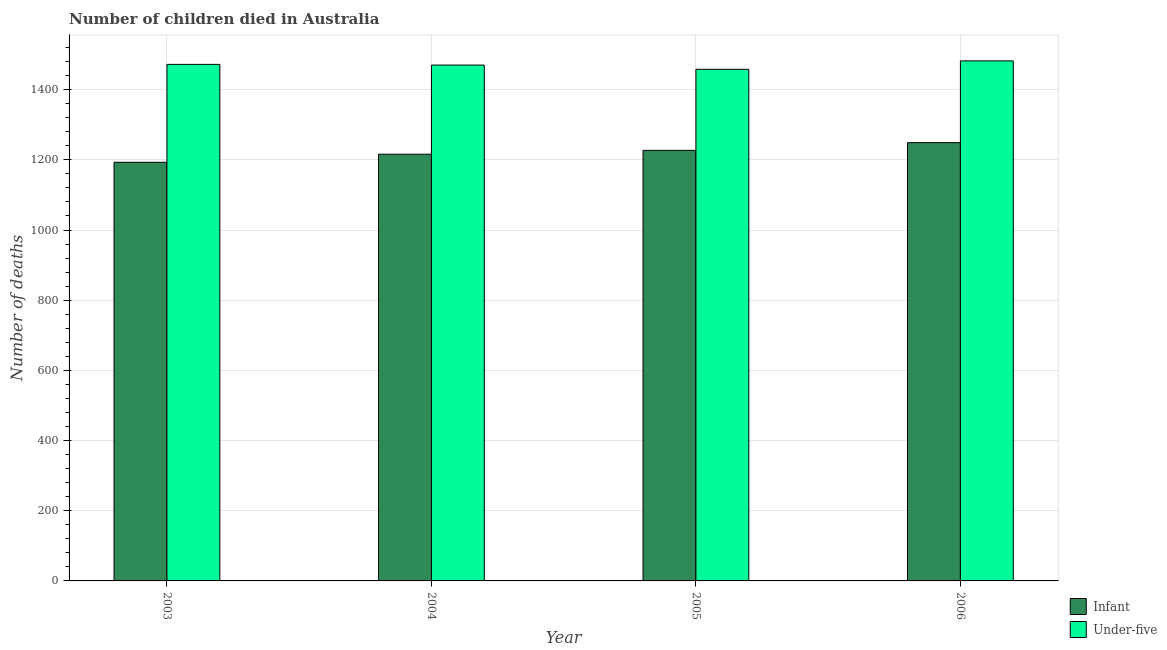How many groups of bars are there?
Your answer should be very brief. 4. Are the number of bars per tick equal to the number of legend labels?
Make the answer very short. Yes. What is the label of the 1st group of bars from the left?
Keep it short and to the point. 2003. In how many cases, is the number of bars for a given year not equal to the number of legend labels?
Give a very brief answer. 0. What is the number of under-five deaths in 2004?
Keep it short and to the point. 1470. Across all years, what is the maximum number of infant deaths?
Offer a very short reply. 1249. Across all years, what is the minimum number of infant deaths?
Provide a short and direct response. 1193. In which year was the number of infant deaths maximum?
Give a very brief answer. 2006. In which year was the number of under-five deaths minimum?
Provide a short and direct response. 2005. What is the total number of infant deaths in the graph?
Give a very brief answer. 4885. What is the difference between the number of infant deaths in 2004 and that in 2005?
Keep it short and to the point. -11. What is the difference between the number of infant deaths in 2003 and the number of under-five deaths in 2005?
Give a very brief answer. -34. What is the average number of under-five deaths per year?
Offer a very short reply. 1470.5. In how many years, is the number of under-five deaths greater than 280?
Provide a succinct answer. 4. What is the ratio of the number of under-five deaths in 2004 to that in 2006?
Provide a short and direct response. 0.99. Is the difference between the number of infant deaths in 2005 and 2006 greater than the difference between the number of under-five deaths in 2005 and 2006?
Provide a short and direct response. No. What is the difference between the highest and the lowest number of under-five deaths?
Provide a succinct answer. 24. In how many years, is the number of under-five deaths greater than the average number of under-five deaths taken over all years?
Make the answer very short. 2. What does the 1st bar from the left in 2004 represents?
Offer a very short reply. Infant. What does the 1st bar from the right in 2006 represents?
Keep it short and to the point. Under-five. How many bars are there?
Your answer should be very brief. 8. Are all the bars in the graph horizontal?
Provide a succinct answer. No. What is the difference between two consecutive major ticks on the Y-axis?
Your answer should be very brief. 200. Are the values on the major ticks of Y-axis written in scientific E-notation?
Give a very brief answer. No. Where does the legend appear in the graph?
Provide a succinct answer. Bottom right. What is the title of the graph?
Your answer should be compact. Number of children died in Australia. What is the label or title of the Y-axis?
Offer a terse response. Number of deaths. What is the Number of deaths in Infant in 2003?
Give a very brief answer. 1193. What is the Number of deaths in Under-five in 2003?
Your response must be concise. 1472. What is the Number of deaths in Infant in 2004?
Keep it short and to the point. 1216. What is the Number of deaths in Under-five in 2004?
Provide a short and direct response. 1470. What is the Number of deaths of Infant in 2005?
Make the answer very short. 1227. What is the Number of deaths of Under-five in 2005?
Your response must be concise. 1458. What is the Number of deaths in Infant in 2006?
Keep it short and to the point. 1249. What is the Number of deaths in Under-five in 2006?
Provide a succinct answer. 1482. Across all years, what is the maximum Number of deaths in Infant?
Make the answer very short. 1249. Across all years, what is the maximum Number of deaths in Under-five?
Offer a very short reply. 1482. Across all years, what is the minimum Number of deaths of Infant?
Your answer should be very brief. 1193. Across all years, what is the minimum Number of deaths of Under-five?
Keep it short and to the point. 1458. What is the total Number of deaths in Infant in the graph?
Provide a short and direct response. 4885. What is the total Number of deaths in Under-five in the graph?
Offer a terse response. 5882. What is the difference between the Number of deaths in Infant in 2003 and that in 2004?
Your answer should be very brief. -23. What is the difference between the Number of deaths in Under-five in 2003 and that in 2004?
Keep it short and to the point. 2. What is the difference between the Number of deaths in Infant in 2003 and that in 2005?
Provide a succinct answer. -34. What is the difference between the Number of deaths in Under-five in 2003 and that in 2005?
Ensure brevity in your answer.  14. What is the difference between the Number of deaths in Infant in 2003 and that in 2006?
Give a very brief answer. -56. What is the difference between the Number of deaths in Infant in 2004 and that in 2005?
Ensure brevity in your answer.  -11. What is the difference between the Number of deaths of Infant in 2004 and that in 2006?
Provide a succinct answer. -33. What is the difference between the Number of deaths of Under-five in 2004 and that in 2006?
Offer a very short reply. -12. What is the difference between the Number of deaths in Infant in 2005 and that in 2006?
Your answer should be compact. -22. What is the difference between the Number of deaths in Under-five in 2005 and that in 2006?
Provide a succinct answer. -24. What is the difference between the Number of deaths in Infant in 2003 and the Number of deaths in Under-five in 2004?
Ensure brevity in your answer.  -277. What is the difference between the Number of deaths of Infant in 2003 and the Number of deaths of Under-five in 2005?
Your answer should be compact. -265. What is the difference between the Number of deaths in Infant in 2003 and the Number of deaths in Under-five in 2006?
Offer a terse response. -289. What is the difference between the Number of deaths in Infant in 2004 and the Number of deaths in Under-five in 2005?
Provide a succinct answer. -242. What is the difference between the Number of deaths of Infant in 2004 and the Number of deaths of Under-five in 2006?
Your response must be concise. -266. What is the difference between the Number of deaths in Infant in 2005 and the Number of deaths in Under-five in 2006?
Give a very brief answer. -255. What is the average Number of deaths of Infant per year?
Your answer should be compact. 1221.25. What is the average Number of deaths of Under-five per year?
Make the answer very short. 1470.5. In the year 2003, what is the difference between the Number of deaths of Infant and Number of deaths of Under-five?
Your answer should be compact. -279. In the year 2004, what is the difference between the Number of deaths in Infant and Number of deaths in Under-five?
Provide a succinct answer. -254. In the year 2005, what is the difference between the Number of deaths of Infant and Number of deaths of Under-five?
Make the answer very short. -231. In the year 2006, what is the difference between the Number of deaths of Infant and Number of deaths of Under-five?
Ensure brevity in your answer.  -233. What is the ratio of the Number of deaths in Infant in 2003 to that in 2004?
Offer a very short reply. 0.98. What is the ratio of the Number of deaths of Infant in 2003 to that in 2005?
Provide a short and direct response. 0.97. What is the ratio of the Number of deaths in Under-five in 2003 to that in 2005?
Provide a succinct answer. 1.01. What is the ratio of the Number of deaths of Infant in 2003 to that in 2006?
Provide a short and direct response. 0.96. What is the ratio of the Number of deaths of Under-five in 2003 to that in 2006?
Give a very brief answer. 0.99. What is the ratio of the Number of deaths of Under-five in 2004 to that in 2005?
Offer a very short reply. 1.01. What is the ratio of the Number of deaths of Infant in 2004 to that in 2006?
Your response must be concise. 0.97. What is the ratio of the Number of deaths of Under-five in 2004 to that in 2006?
Your response must be concise. 0.99. What is the ratio of the Number of deaths in Infant in 2005 to that in 2006?
Give a very brief answer. 0.98. What is the ratio of the Number of deaths of Under-five in 2005 to that in 2006?
Make the answer very short. 0.98. What is the difference between the highest and the second highest Number of deaths in Infant?
Give a very brief answer. 22. What is the difference between the highest and the second highest Number of deaths of Under-five?
Your answer should be compact. 10. 